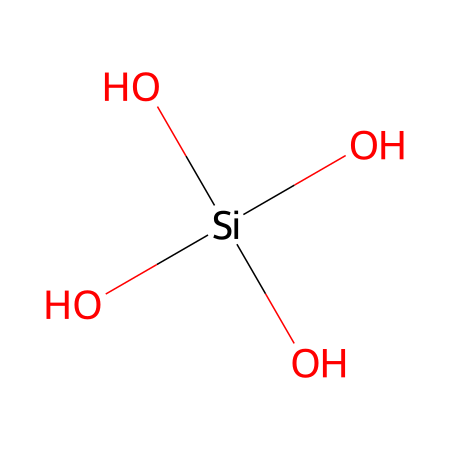What is the central atom in this chemical? The chemical structure has silicon (Si) as the main element surrounded by four hydroxyl (OH) groups. This is evident because the silicon atom is at the center of the structure.
Answer: silicon How many hydroxyl groups are present in this compound? Each (OH) in the structural formula indicates a hydroxyl group. Since there are four (OH) groups in the structure, you can count them to find there are four hydroxyl groups.
Answer: four What is the degree of oxidation of the silicon atom in this compound? The silicon is connected to four oxygen atoms in the form of hydroxyl groups (O) and each contributes a negative charge, making silicon have a positive oxidation state. Each oxygen being bonded to -1 accounts for a total of -4 due to the four hydroxyl groups. Therefore, the oxidation state of silicon is +4.
Answer: +4 Is this chemical considered a silane? Silanes typically have silicon bonded to hydrogen or hydrocarbons but in this case, silicon is bonded to hydroxyl groups instead. This compound, with only oxygen attachments and no hydrogen as a substituent, is also part of the broader group of silicates but not a classical silane.
Answer: no What is the total number of oxygen atoms in this chemical? There are four hydroxyl groups, and since each hydroxyl group contains one oxygen atom, the total number of oxygen atoms present in the structure is four.
Answer: four 